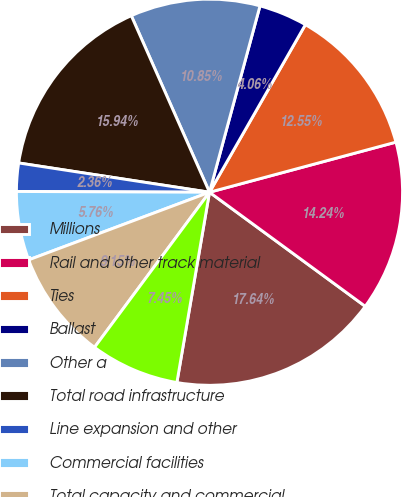Convert chart. <chart><loc_0><loc_0><loc_500><loc_500><pie_chart><fcel>Millions<fcel>Rail and other track material<fcel>Ties<fcel>Ballast<fcel>Other a<fcel>Total road infrastructure<fcel>Line expansion and other<fcel>Commercial facilities<fcel>Total capacity and commercial<fcel>Locomotives and freight cars<nl><fcel>17.64%<fcel>14.24%<fcel>12.55%<fcel>4.06%<fcel>10.85%<fcel>15.94%<fcel>2.36%<fcel>5.76%<fcel>9.15%<fcel>7.45%<nl></chart> 